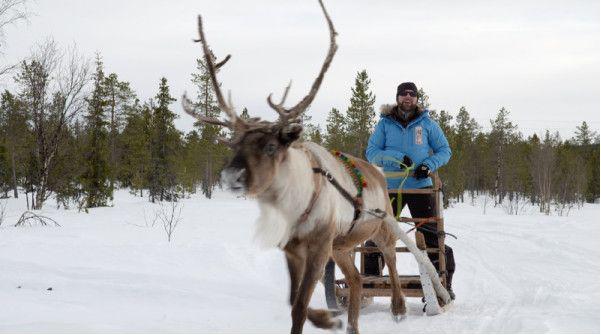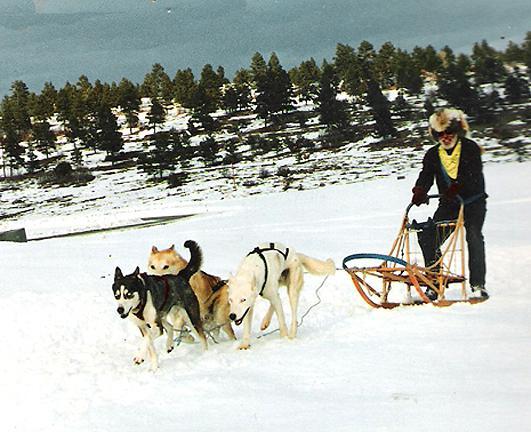The first image is the image on the left, the second image is the image on the right. Examine the images to the left and right. Is the description "The right image shows one person standing behind a small sled pulled by no more than two dogs and heading rightward." accurate? Answer yes or no. No. The first image is the image on the left, the second image is the image on the right. Examine the images to the left and right. Is the description "There are more than four animals in harnesses." accurate? Answer yes or no. No. 